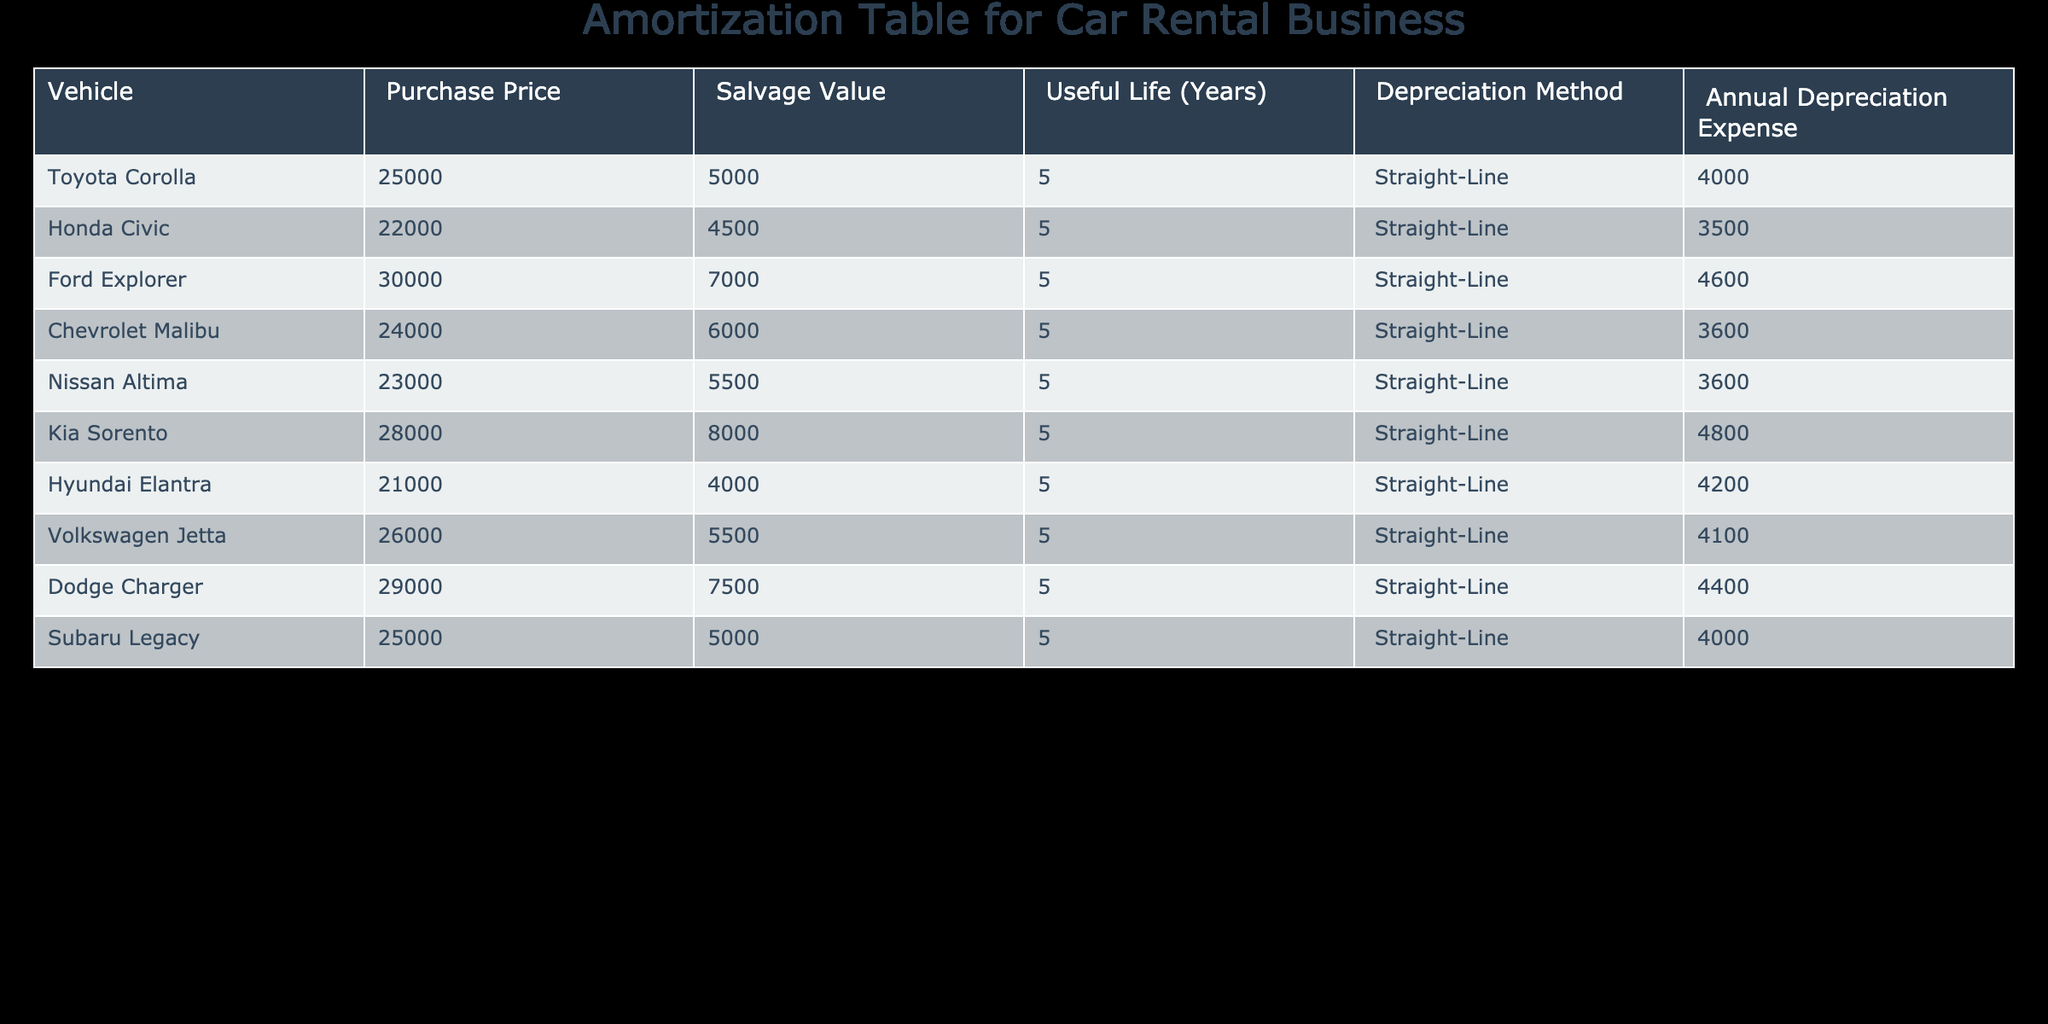What is the Purchase Price of the Ford Explorer? The Purchase Price of the Ford Explorer can be found in the table under the column labeled "Purchase Price." According to the table, the Purchase Price for the Ford Explorer is 30000.
Answer: 30000 What is the Annual Depreciation Expense of the Honda Civic? The Annual Depreciation Expense of the Honda Civic is directly listed in the column "Annual Depreciation Expense." The table shows this value as 3500.
Answer: 3500 Which vehicle has the highest Salvage Value? To find the vehicle with the highest Salvage Value, we compare the values in the "Salvage Value" column. The maximum value found is 8000 for the Kia Sorento.
Answer: Kia Sorento What is the average Annual Depreciation Expense for all vehicles? To find the average Annual Depreciation Expense, we first sum up all the values in the "Annual Depreciation Expense" column: 4000 + 3500 + 4600 + 3600 + 3600 + 4800 + 4200 + 4100 + 4400 + 4000 = 42600. There are 10 vehicles, so the average is 42600 / 10 = 4260.
Answer: 4260 Is the Hyundai Elantra's Purchase Price higher than the Volkswagen Jetta's? We compare the Purchase Prices in the "Purchase Price" column: Hyundai Elantra is 21000, and Volkswagen Jetta is 26000. Therefore, 21000 is not higher than 26000, making the statement false.
Answer: No Which vehicle has the lowest Annual Depreciation Expense? To determine the vehicle with the lowest Annual Depreciation Expense, we examine the values under the "Annual Depreciation Expense" column. The lowest value is 3500 for the Honda Civic.
Answer: Honda Civic What is the difference in Purchase Price between the highest and lowest valued vehicles? The highest Purchase Price is 30000 for the Ford Explorer and the lowest is 21000 for the Hyundai Elantra. The difference is calculated as 30000 - 21000 = 9000.
Answer: 9000 Are all vehicles listed in the table depreciated using the Straight-Line method? By examining the "Depreciation Method" column, we see that all vehicles are indeed categorized under the Straight-Line method. Therefore, the statement is true.
Answer: Yes What is the total Salvage Value for all vehicles combined? To find the total Salvage Value, we sum the values in the "Salvage Value" column: 5000 + 4500 + 7000 + 6000 + 5500 + 8000 + 4000 + 5500 + 7500 + 5000 = 52500.
Answer: 52500 What is the vehicle with the highest Purchase Price, and what is its annual depreciation expense? Upon examining the "Purchase Price" column, we find that the Ford Explorer has the highest Purchase Price of 30000. Its Annual Depreciation Expense is found in the same row, which is 4600.
Answer: Ford Explorer, 4600 